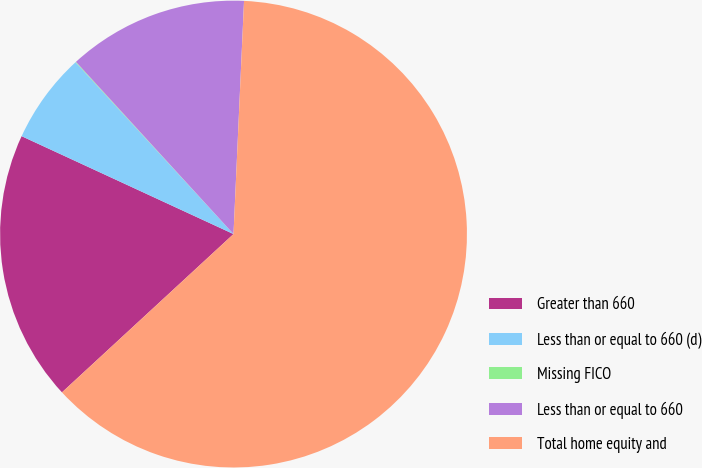<chart> <loc_0><loc_0><loc_500><loc_500><pie_chart><fcel>Greater than 660<fcel>Less than or equal to 660 (d)<fcel>Missing FICO<fcel>Less than or equal to 660<fcel>Total home equity and<nl><fcel>18.75%<fcel>6.28%<fcel>0.04%<fcel>12.51%<fcel>62.42%<nl></chart> 